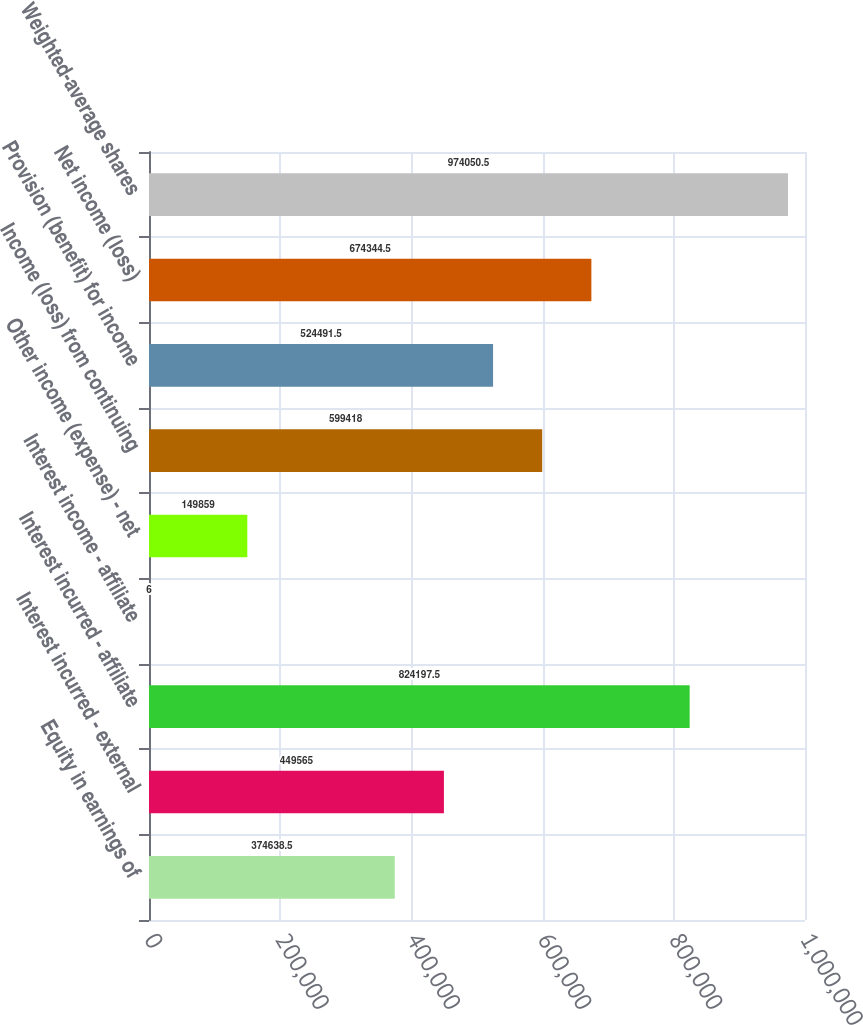<chart> <loc_0><loc_0><loc_500><loc_500><bar_chart><fcel>Equity in earnings of<fcel>Interest incurred - external<fcel>Interest incurred - affiliate<fcel>Interest income - affiliate<fcel>Other income (expense) - net<fcel>Income (loss) from continuing<fcel>Provision (benefit) for income<fcel>Net income (loss)<fcel>Weighted-average shares<nl><fcel>374638<fcel>449565<fcel>824198<fcel>6<fcel>149859<fcel>599418<fcel>524492<fcel>674344<fcel>974050<nl></chart> 